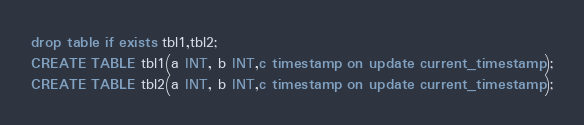<code> <loc_0><loc_0><loc_500><loc_500><_SQL_>drop table if exists tbl1,tbl2;
CREATE TABLE tbl1(a INT, b INT,c timestamp on update current_timestamp);
CREATE TABLE tbl2(a INT, b INT,c timestamp on update current_timestamp);</code> 